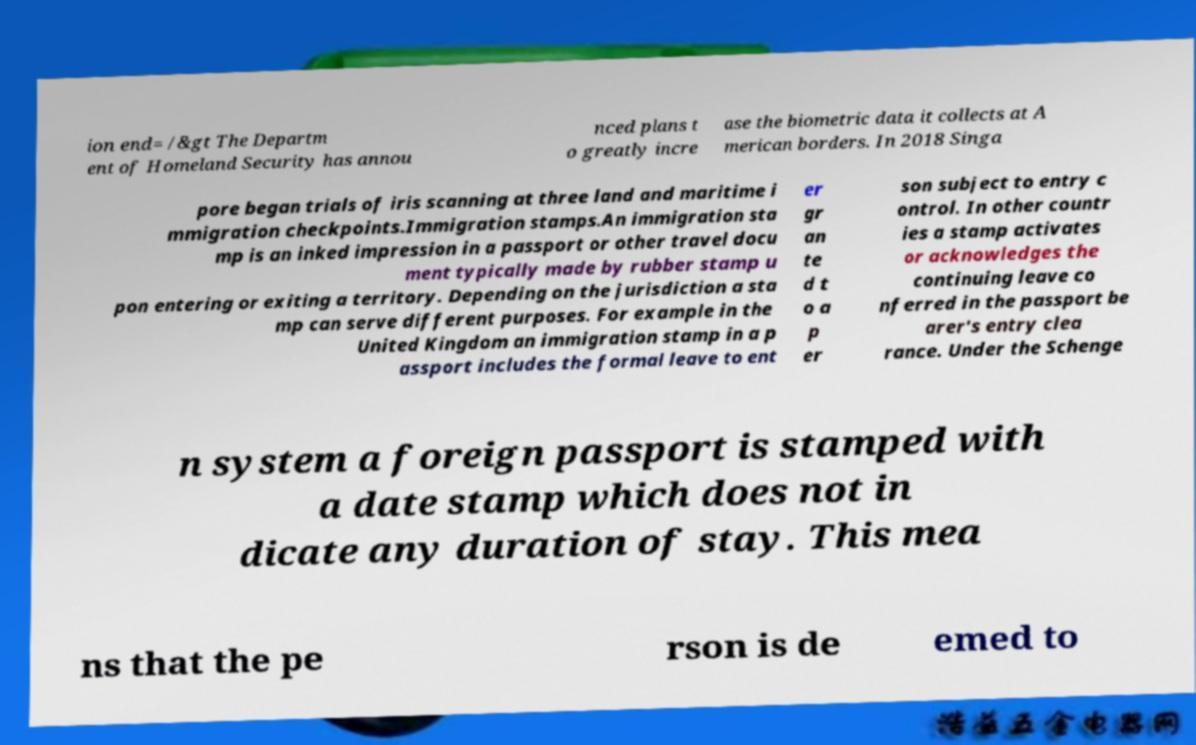For documentation purposes, I need the text within this image transcribed. Could you provide that? ion end= /&gt The Departm ent of Homeland Security has annou nced plans t o greatly incre ase the biometric data it collects at A merican borders. In 2018 Singa pore began trials of iris scanning at three land and maritime i mmigration checkpoints.Immigration stamps.An immigration sta mp is an inked impression in a passport or other travel docu ment typically made by rubber stamp u pon entering or exiting a territory. Depending on the jurisdiction a sta mp can serve different purposes. For example in the United Kingdom an immigration stamp in a p assport includes the formal leave to ent er gr an te d t o a p er son subject to entry c ontrol. In other countr ies a stamp activates or acknowledges the continuing leave co nferred in the passport be arer's entry clea rance. Under the Schenge n system a foreign passport is stamped with a date stamp which does not in dicate any duration of stay. This mea ns that the pe rson is de emed to 